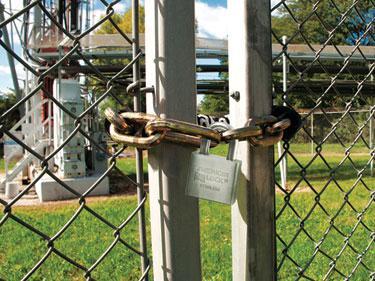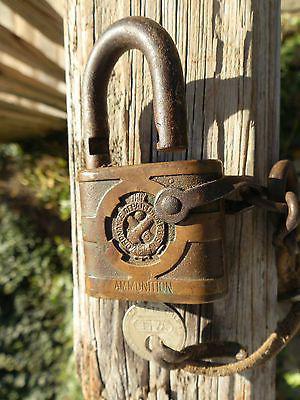The first image is the image on the left, the second image is the image on the right. Analyze the images presented: Is the assertion "There is one lock without a key in the right image." valid? Answer yes or no. Yes. 